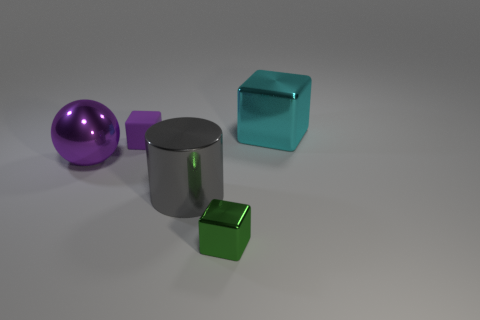Are there any cyan cubes made of the same material as the large cylinder?
Ensure brevity in your answer.  Yes. Is there a tiny green metallic cube behind the tiny block in front of the purple rubber object?
Provide a short and direct response. No. What is the material of the purple object that is to the left of the tiny purple block?
Keep it short and to the point. Metal. Is the gray shiny object the same shape as the small green shiny thing?
Your response must be concise. No. There is a metallic cube that is to the left of the big cyan metal object that is right of the tiny object that is in front of the tiny purple rubber cube; what color is it?
Offer a very short reply. Green. How many cyan matte things have the same shape as the green metallic object?
Your answer should be very brief. 0. How big is the shiny block on the right side of the shiny thing that is in front of the gray shiny cylinder?
Offer a terse response. Large. Is the gray metal cylinder the same size as the purple block?
Your response must be concise. No. Are there any large gray things that are behind the cube left of the shiny block left of the large metal cube?
Your response must be concise. No. How big is the gray metal cylinder?
Offer a terse response. Large. 